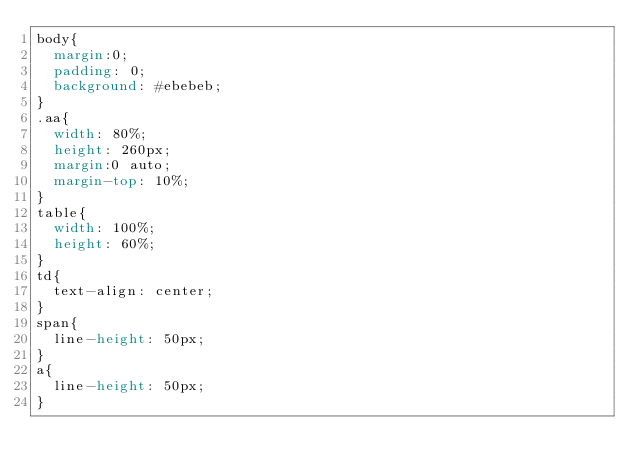Convert code to text. <code><loc_0><loc_0><loc_500><loc_500><_CSS_>body{
	margin:0;
	padding: 0;
	background: #ebebeb;
}
.aa{
	width: 80%;
	height: 260px;
	margin:0 auto;
	margin-top: 10%;
}
table{
	width: 100%;
	height: 60%;
}
td{
	text-align: center;
}
span{
	line-height: 50px;
}
a{
	line-height: 50px;
}</code> 